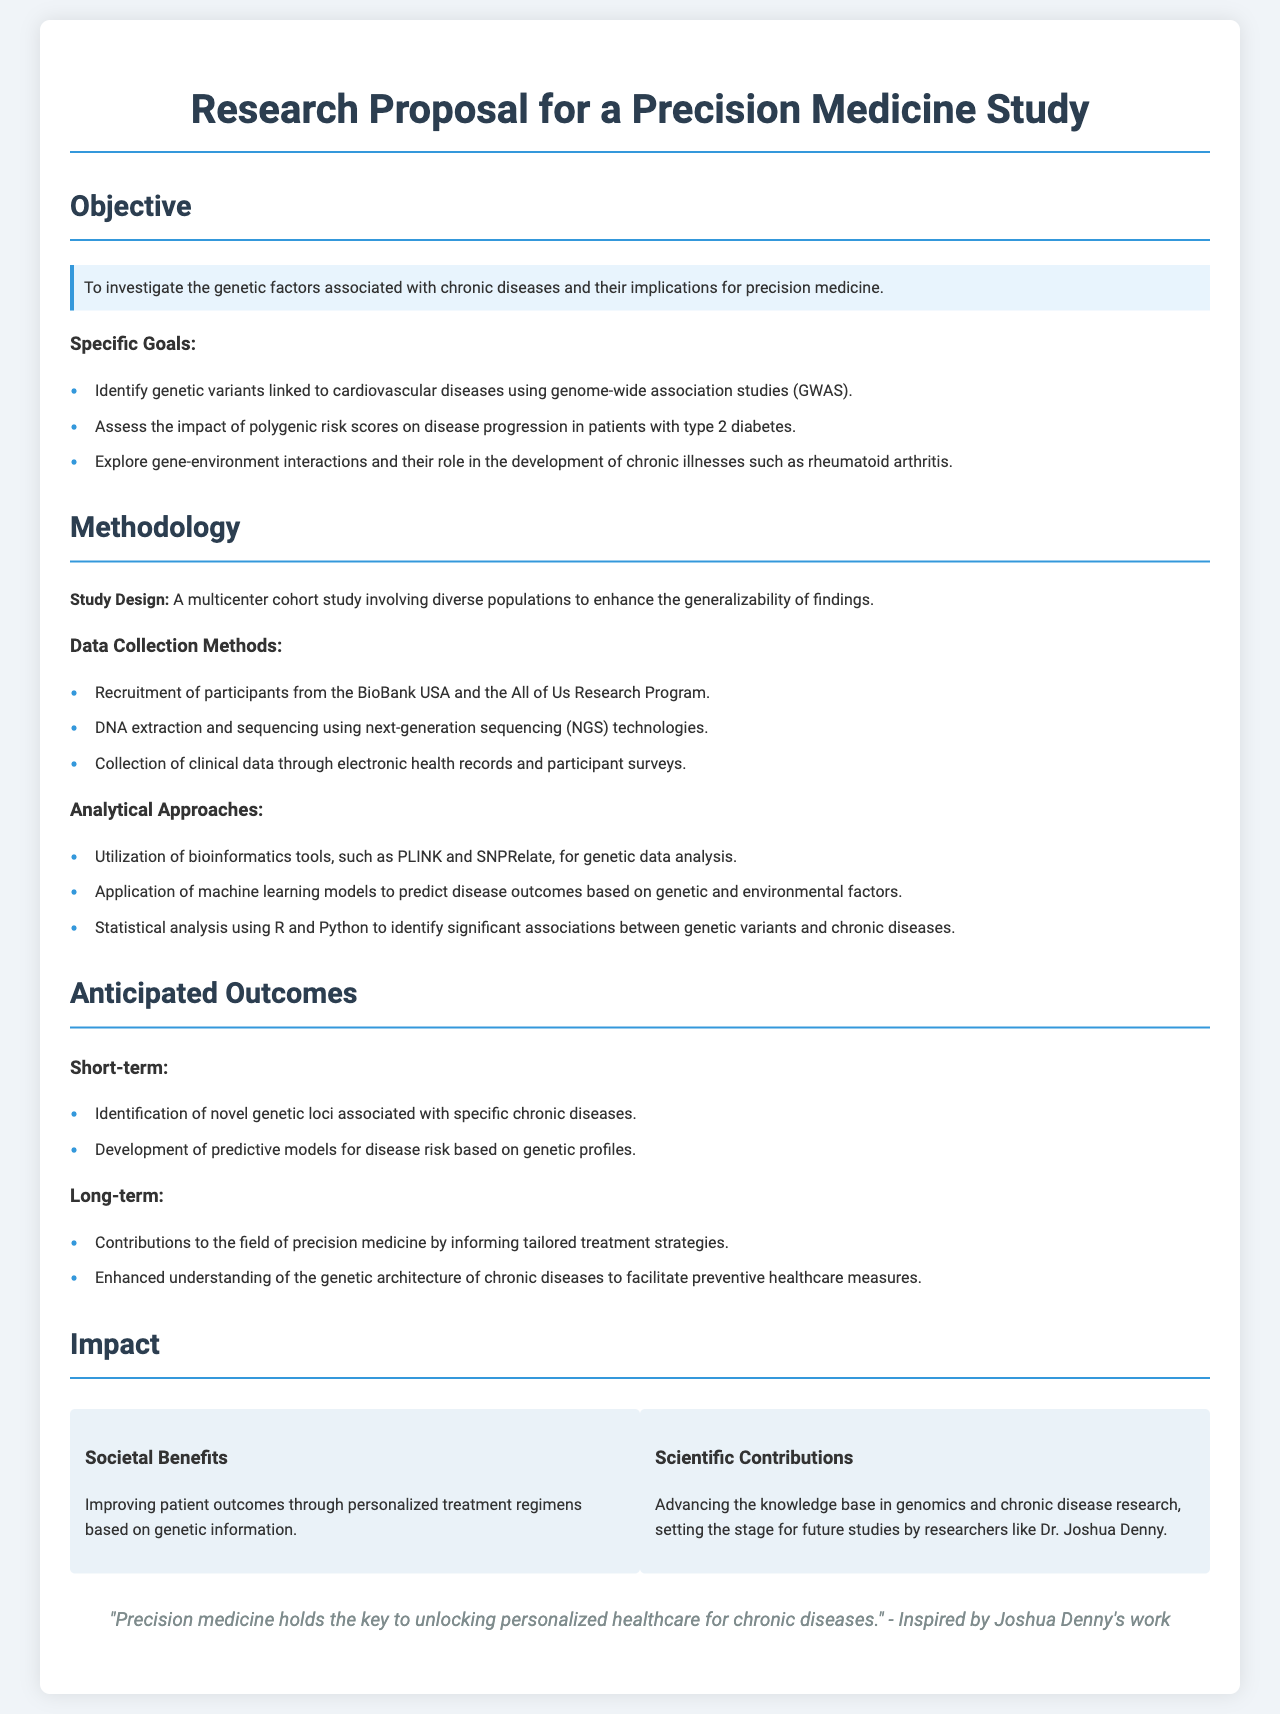What is the primary objective of the research proposal? The primary objective is stated in the document as investigating the genetic factors associated with chronic diseases and their implications for precision medicine.
Answer: Investigate genetic factors associated with chronic diseases What type of study design is used in this proposal? The document specifies that the study design is a multicenter cohort study involving diverse populations.
Answer: Multicenter cohort study Which genetic analysis tools are mentioned for data analysis? The proposal lists bioinformatics tools including PLINK and SNPRelate for genetic data analysis.
Answer: PLINK and SNPRelate What are the anticipated short-term outcomes of the study? The document mentions two short-term outcomes: Identification of novel genetic loci and development of predictive models.
Answer: Identification of novel genetic loci, Development of predictive models What long-term contributions to precision medicine does the study aim to achieve? The long-term outcomes are described as contributions to the field by informing tailored treatment strategies and enhancing understanding of genetic architecture.
Answer: Tailored treatment strategies, understanding of genetic architecture What is the source of participants for data collection? The document specifies that participants will be recruited from BioBank USA and the All of Us Research Program.
Answer: BioBank USA and the All of Us Research Program Who is acknowledged for advancing knowledge in genomics through future studies? The document highlights that Dr. Joshua Denny's work sets the stage for future studies in genomics and chronic disease research.
Answer: Dr. Joshua Denny What is the main societal benefit mentioned in the impact section? The societal benefit discusses improving patient outcomes through personalized treatment regimens based on genetic information.
Answer: Improving patient outcomes through personalized treatment regimens 